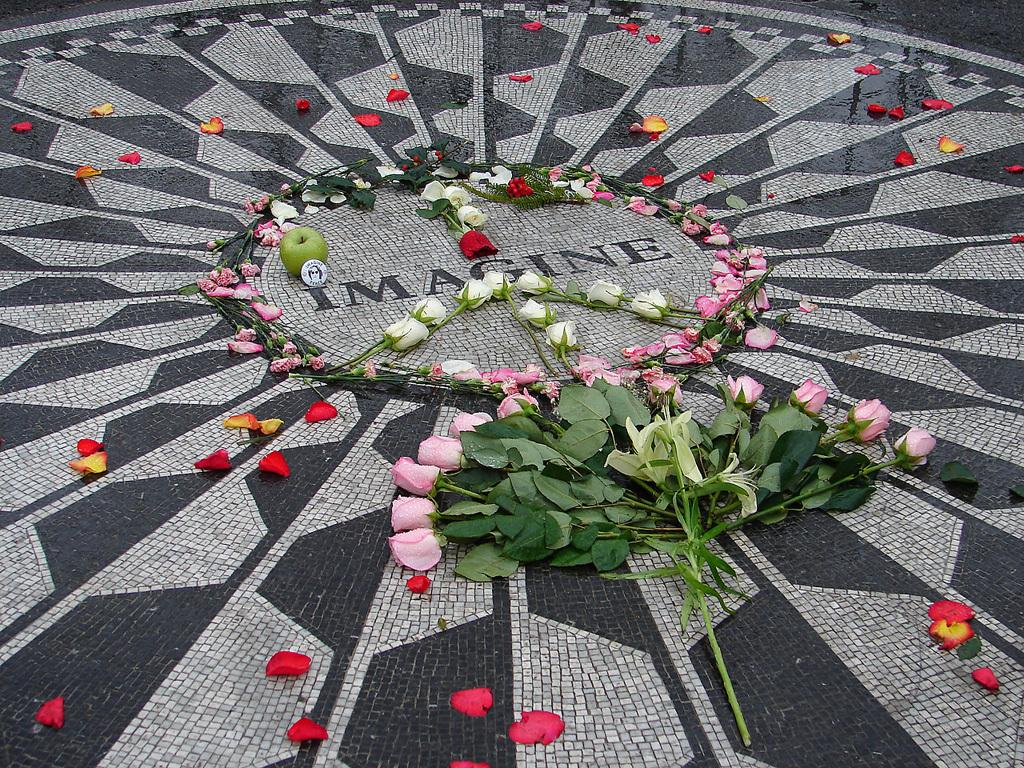What type of fruit is in the image? There is a green apple in the image. What other objects can be seen in the image? There is a badge and various roses in the image, including red, white, and pink roses. What is the color of the green apple? The color of the green apple is green. What is the condition of the roses in the image? The roses in the image are red, white, and pink. What might be the reason for the flower petals on the floor in the image? The flower petals on the floor might be the result of the roses losing their petals. What type of government is depicted in the image? There is no depiction of a government in the image; it features a green apple, a badge, and various roses. What role does the police play in the image? There is no mention of the police in the image; it focuses on a green apple, a badge, and various roses. 